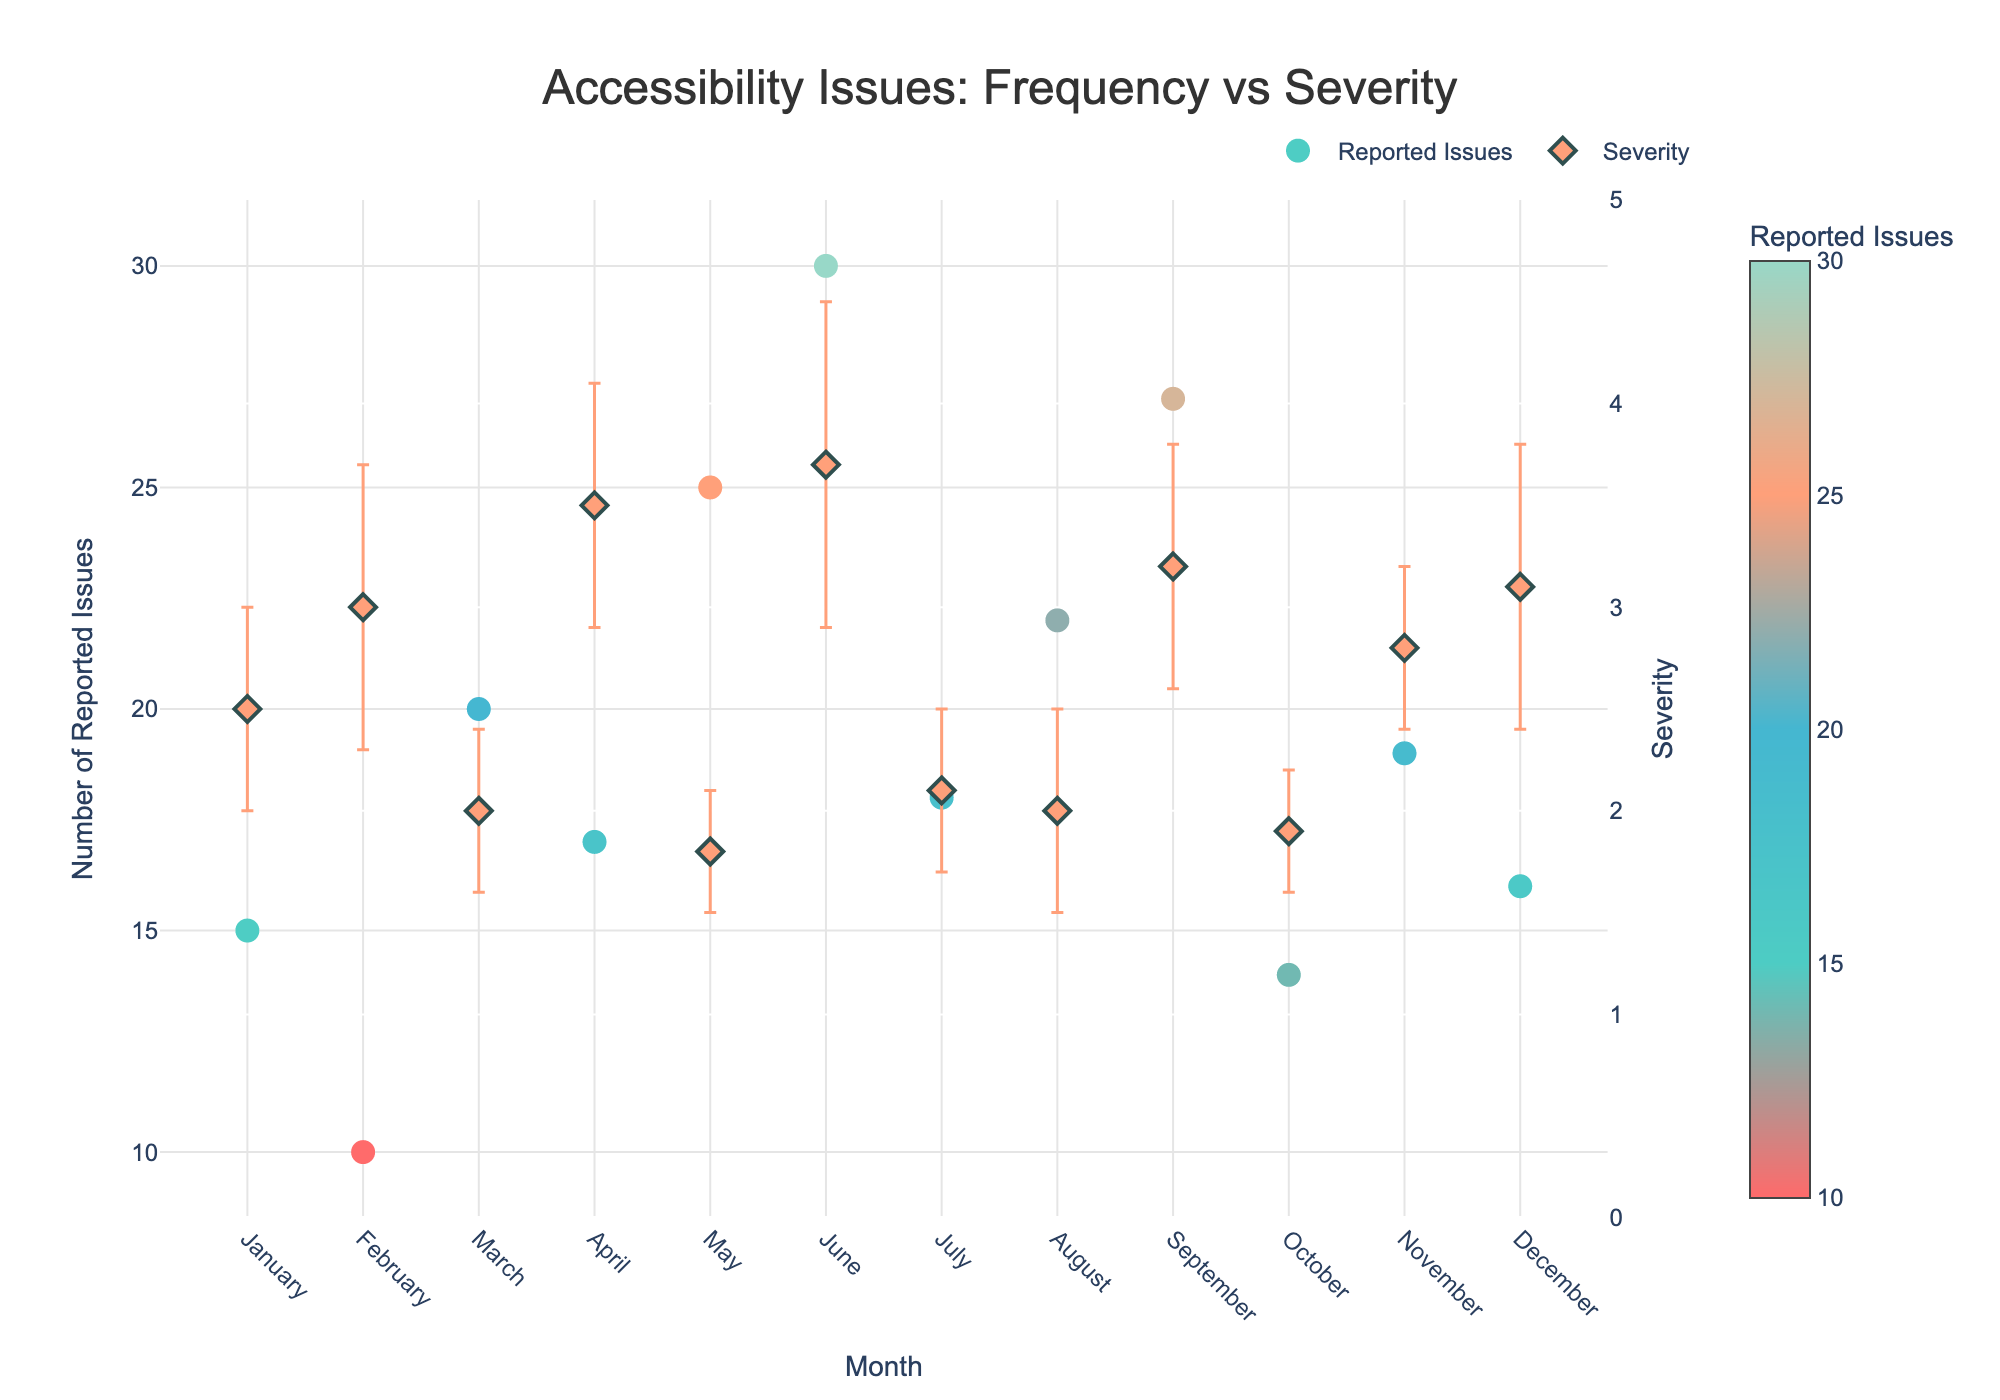When is the highest frequency of reported issues? By looking at the scatter plot, the highest frequency is represented by the tallest point on the y-axis. This occurs in June with 30 reported issues
Answer: June Which month has the lowest severity of accessibility issues? The severity in each month also includes error bars. By identifying the marker with the lowest central value on the right y-axis, May stands out with 1.8 severity
Answer: May Compare the number of reported issues between February and September Locate the points for February and September on the left y-axis. February has 10 reported issues, and September has 27 reported issues, making it clear that September has more reported issues
Answer: September has more What is the average severity of accessibility issues over the year? Add up the severity values for each month and divide by the number of months: (2.5 + 3.0 + 2.0 + 3.5 + 1.8 + 3.7 + 2.1 + 2.0 + 3.2 + 1.9 + 2.8 + 3.1) / 12 = 2.63
Answer: 2.63 What's the difference in reported issues between the months with the highest and lowest frequency? Calculate the reported issues in June (30) and February (10), then subtract the lesser value from the greater: 30 - 10 = 20
Answer: 20 Which month has the highest severity and by how much does it exceed the preceding month's severity? June has the highest severity at 3.7. The preceding month, May, has a severity of 1.8. The difference is 3.7 - 1.8 = 1.9
Answer: June, 1.9 What can be said about the trend in the number of reported issues from January to December? From the plot, identify the general direction of the points representing reported issues. The number varies month to month but shows a notable peak in June and is generally higher in the summer months
Answer: Varies with a peak in June, higher in summer How does the severity of issues in October compare to April? October's severity is 1.9 while April's severity is 3.5. Comparing these, April has a higher severity
Answer: April is higher What's the standard deviation in severity for August, and what does it indicate? In the plot, hover or refer to the error bar for August showing a standard deviation of 0.5. This suggests variability in the severity ratings reported for that month
Answer: 0.5, indicates variability Identify any month(s) where both high severity and a high number of reported issues occurred June has 30 reported issues (highest) and a severity of 3.7 (highest), representing both high counts and high severity of issues
Answer: June 